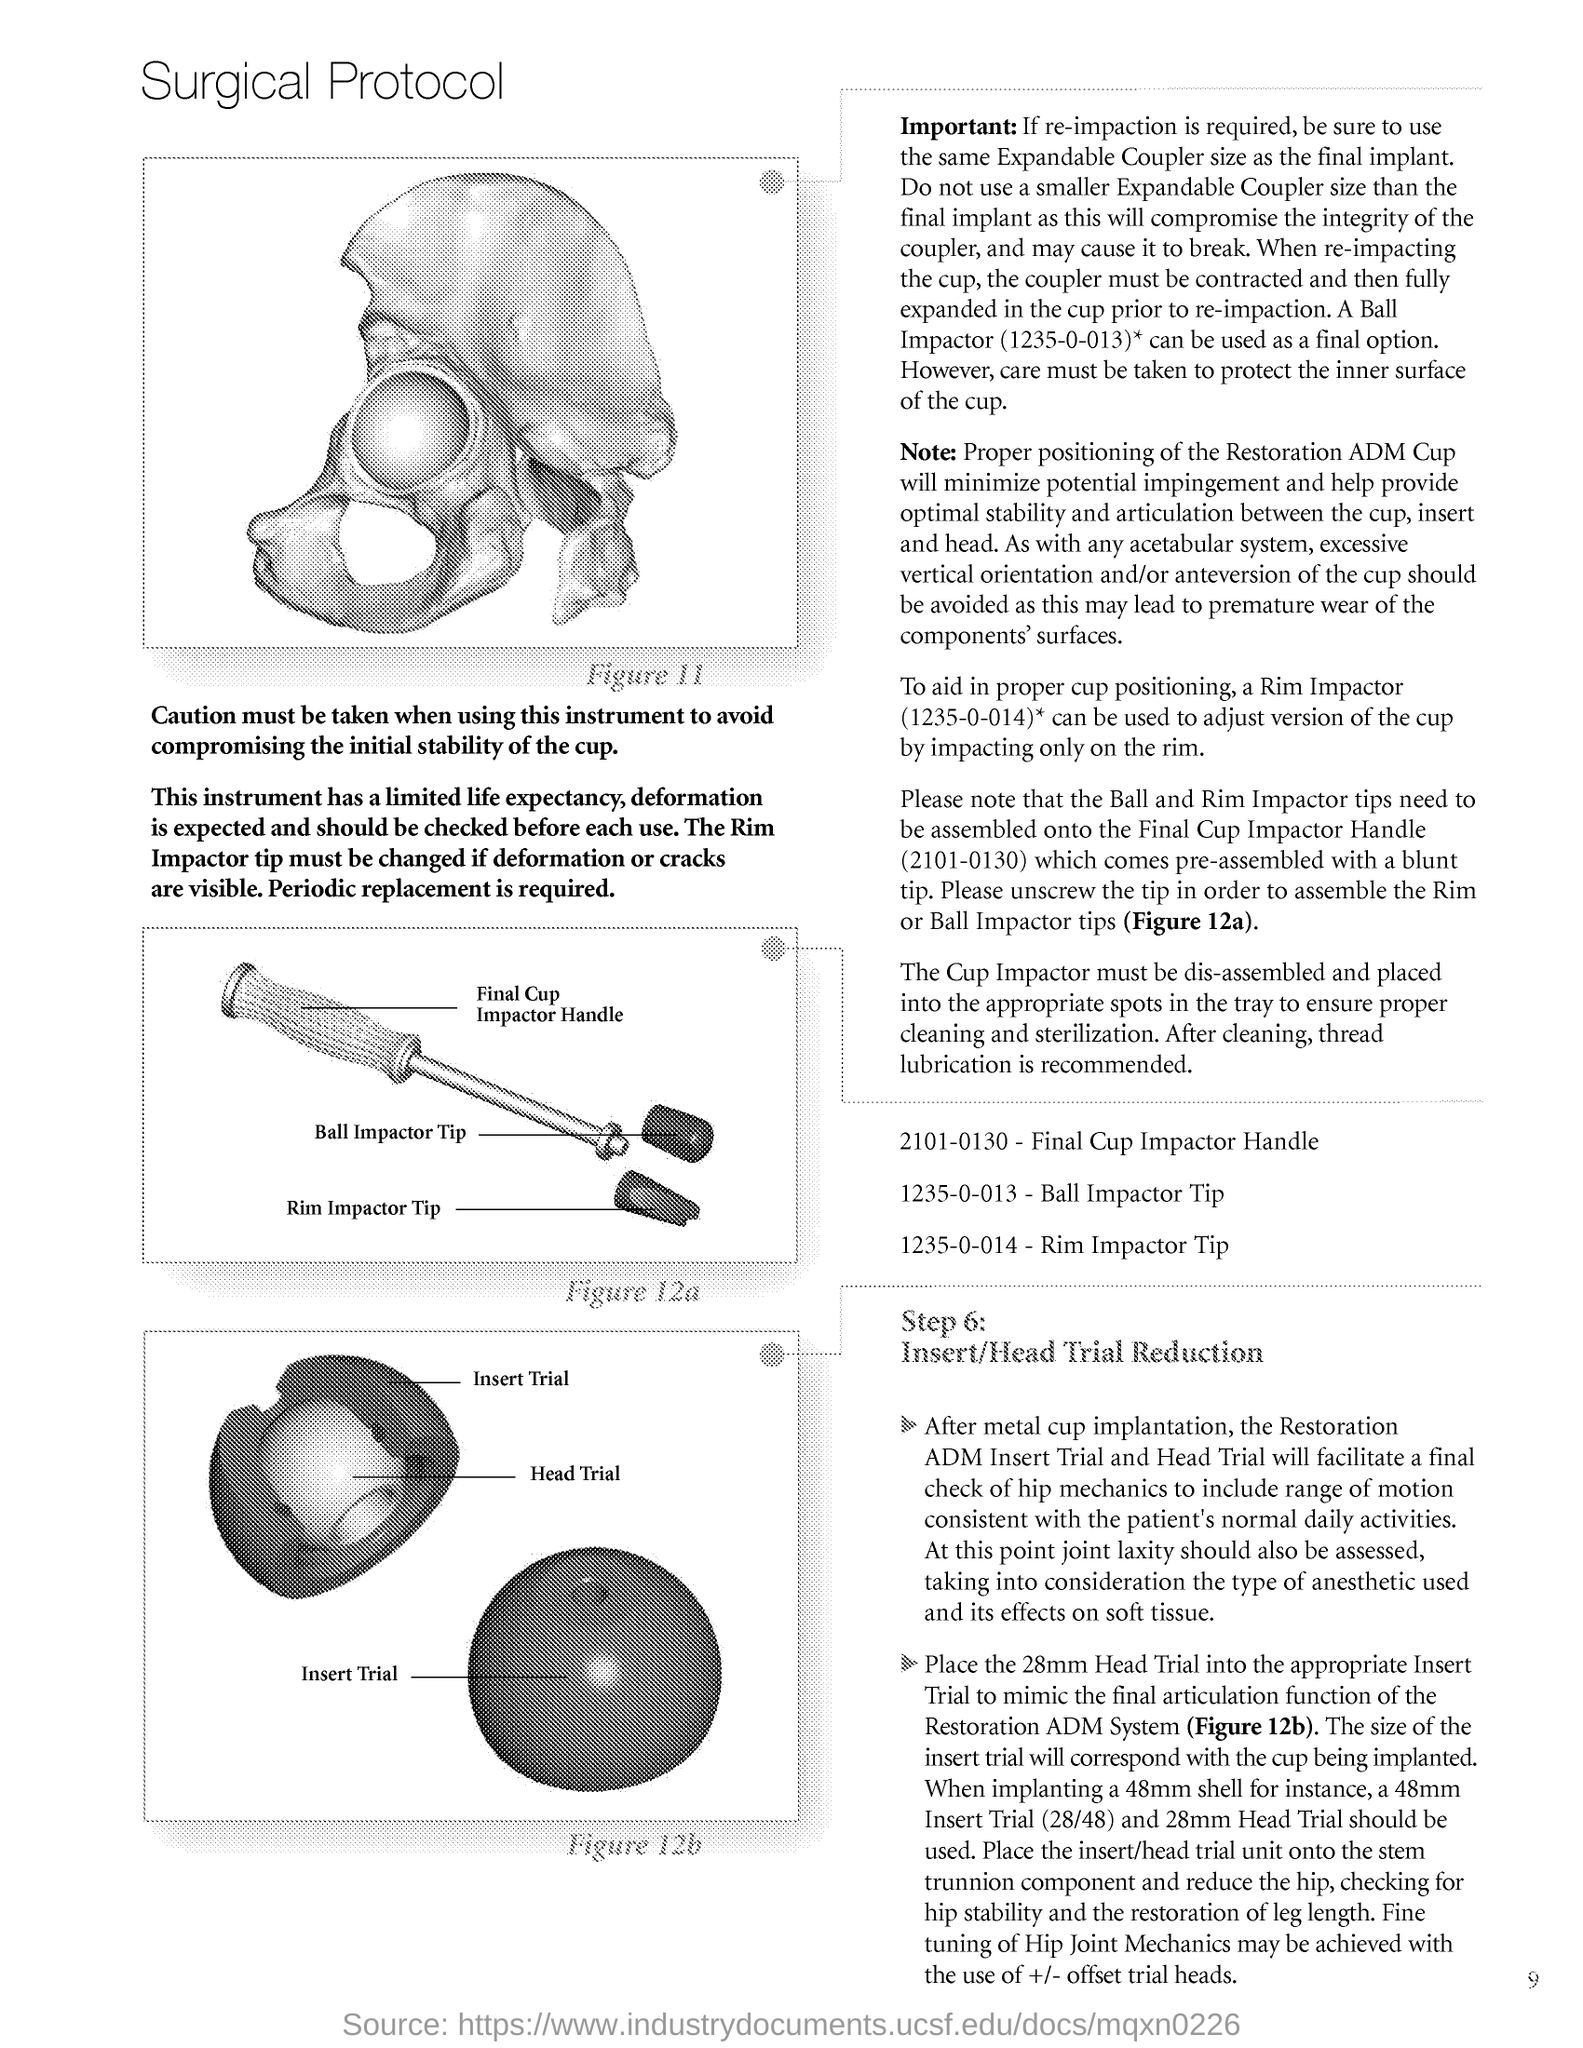What is the title of the document?
Ensure brevity in your answer.  Surgical Protocol. 